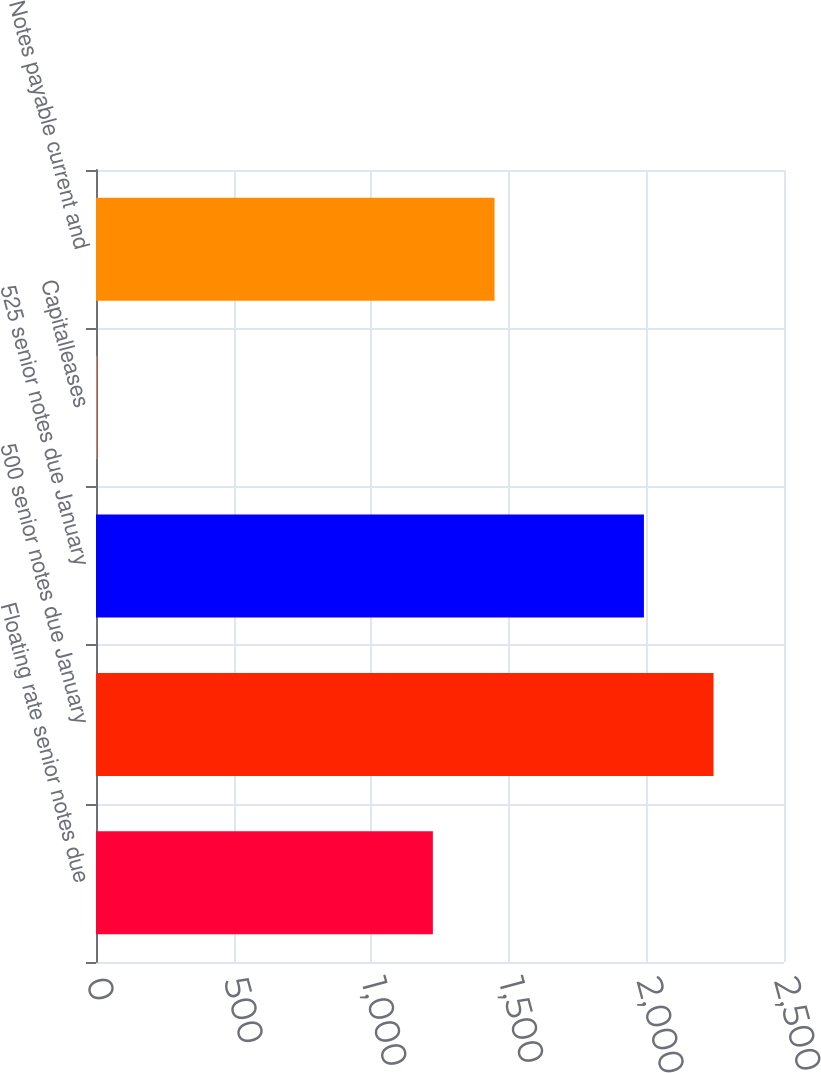<chart> <loc_0><loc_0><loc_500><loc_500><bar_chart><fcel>Floating rate senior notes due<fcel>500 senior notes due January<fcel>525 senior notes due January<fcel>Capitalleases<fcel>Notes payable current and<nl><fcel>1224.1<fcel>2244<fcel>1991<fcel>3<fcel>1448.2<nl></chart> 